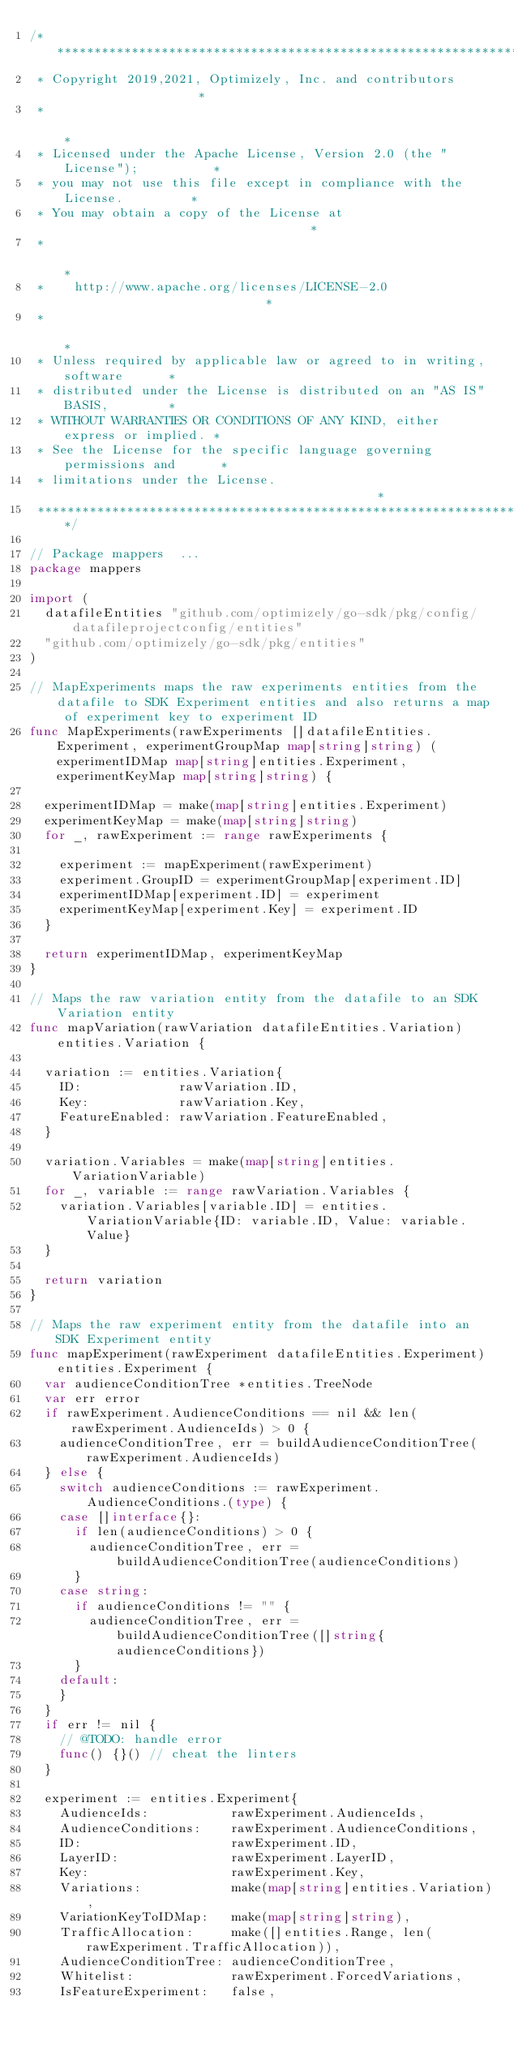<code> <loc_0><loc_0><loc_500><loc_500><_Go_>/****************************************************************************
 * Copyright 2019,2021, Optimizely, Inc. and contributors                   *
 *                                                                          *
 * Licensed under the Apache License, Version 2.0 (the "License");          *
 * you may not use this file except in compliance with the License.         *
 * You may obtain a copy of the License at                                  *
 *                                                                          *
 *    http://www.apache.org/licenses/LICENSE-2.0                            *
 *                                                                          *
 * Unless required by applicable law or agreed to in writing, software      *
 * distributed under the License is distributed on an "AS IS" BASIS,        *
 * WITHOUT WARRANTIES OR CONDITIONS OF ANY KIND, either express or implied. *
 * See the License for the specific language governing permissions and      *
 * limitations under the License.                                           *
 ***************************************************************************/

// Package mappers  ...
package mappers

import (
	datafileEntities "github.com/optimizely/go-sdk/pkg/config/datafileprojectconfig/entities"
	"github.com/optimizely/go-sdk/pkg/entities"
)

// MapExperiments maps the raw experiments entities from the datafile to SDK Experiment entities and also returns a map of experiment key to experiment ID
func MapExperiments(rawExperiments []datafileEntities.Experiment, experimentGroupMap map[string]string) (experimentIDMap map[string]entities.Experiment, experimentKeyMap map[string]string) {

	experimentIDMap = make(map[string]entities.Experiment)
	experimentKeyMap = make(map[string]string)
	for _, rawExperiment := range rawExperiments {

		experiment := mapExperiment(rawExperiment)
		experiment.GroupID = experimentGroupMap[experiment.ID]
		experimentIDMap[experiment.ID] = experiment
		experimentKeyMap[experiment.Key] = experiment.ID
	}

	return experimentIDMap, experimentKeyMap
}

// Maps the raw variation entity from the datafile to an SDK Variation entity
func mapVariation(rawVariation datafileEntities.Variation) entities.Variation {

	variation := entities.Variation{
		ID:             rawVariation.ID,
		Key:            rawVariation.Key,
		FeatureEnabled: rawVariation.FeatureEnabled,
	}

	variation.Variables = make(map[string]entities.VariationVariable)
	for _, variable := range rawVariation.Variables {
		variation.Variables[variable.ID] = entities.VariationVariable{ID: variable.ID, Value: variable.Value}
	}

	return variation
}

// Maps the raw experiment entity from the datafile into an SDK Experiment entity
func mapExperiment(rawExperiment datafileEntities.Experiment) entities.Experiment {
	var audienceConditionTree *entities.TreeNode
	var err error
	if rawExperiment.AudienceConditions == nil && len(rawExperiment.AudienceIds) > 0 {
		audienceConditionTree, err = buildAudienceConditionTree(rawExperiment.AudienceIds)
	} else {
		switch audienceConditions := rawExperiment.AudienceConditions.(type) {
		case []interface{}:
			if len(audienceConditions) > 0 {
				audienceConditionTree, err = buildAudienceConditionTree(audienceConditions)
			}
		case string:
			if audienceConditions != "" {
				audienceConditionTree, err = buildAudienceConditionTree([]string{audienceConditions})
			}
		default:
		}
	}
	if err != nil {
		// @TODO: handle error
		func() {}() // cheat the linters
	}

	experiment := entities.Experiment{
		AudienceIds:           rawExperiment.AudienceIds,
		AudienceConditions:    rawExperiment.AudienceConditions,
		ID:                    rawExperiment.ID,
		LayerID:               rawExperiment.LayerID,
		Key:                   rawExperiment.Key,
		Variations:            make(map[string]entities.Variation),
		VariationKeyToIDMap:   make(map[string]string),
		TrafficAllocation:     make([]entities.Range, len(rawExperiment.TrafficAllocation)),
		AudienceConditionTree: audienceConditionTree,
		Whitelist:             rawExperiment.ForcedVariations,
		IsFeatureExperiment:   false,</code> 